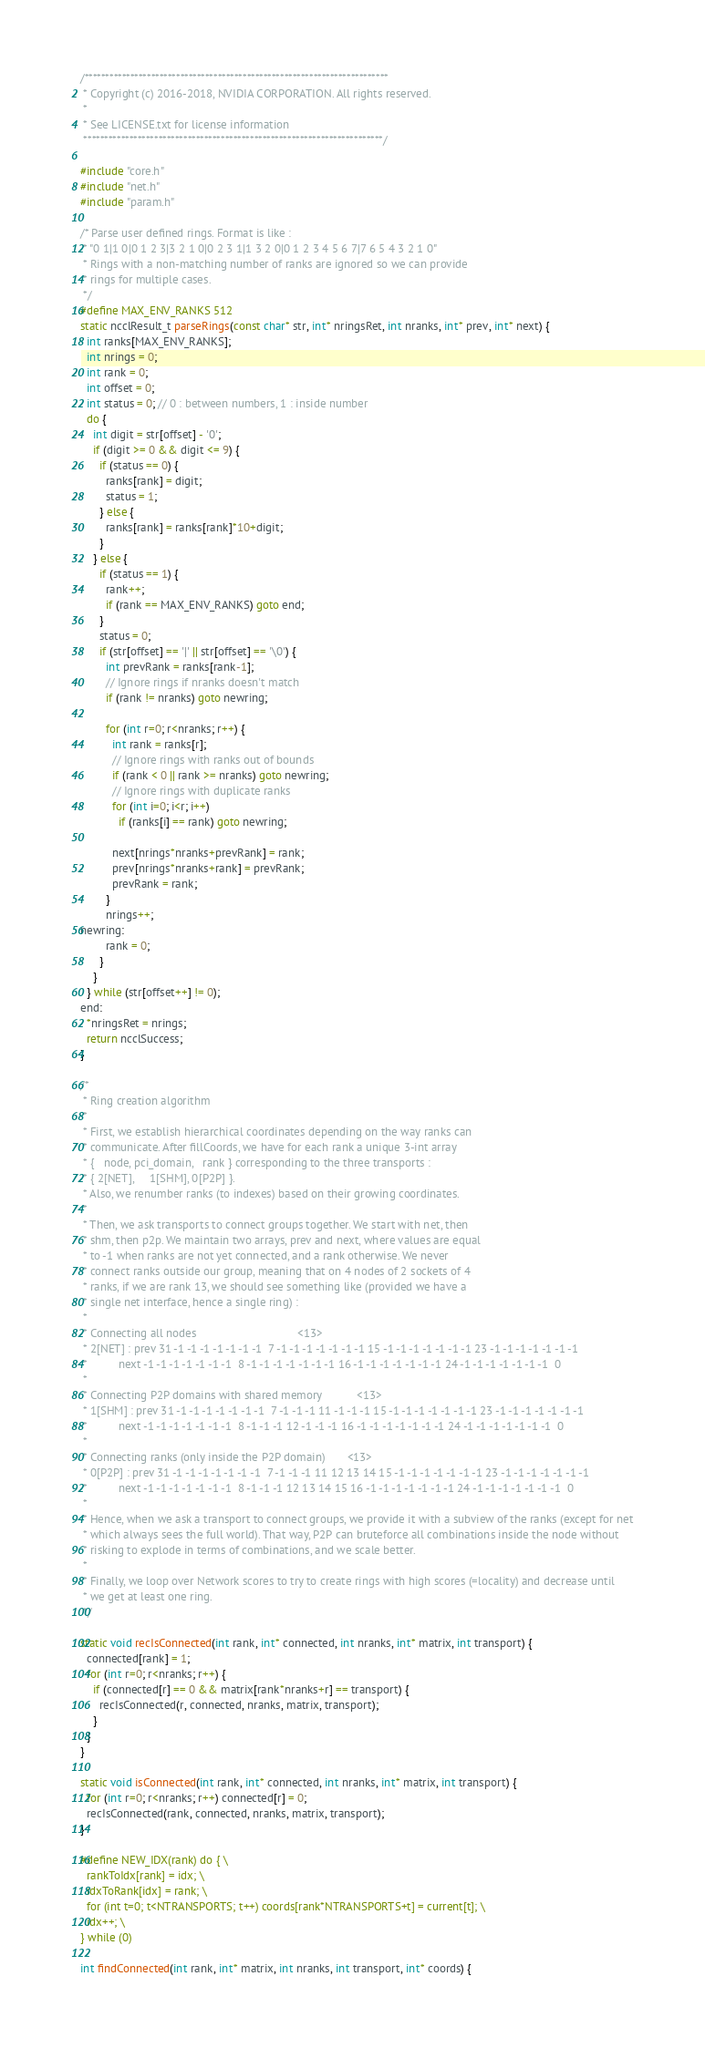Convert code to text. <code><loc_0><loc_0><loc_500><loc_500><_Cuda_>/*************************************************************************
 * Copyright (c) 2016-2018, NVIDIA CORPORATION. All rights reserved.
 *
 * See LICENSE.txt for license information
 ************************************************************************/

#include "core.h"
#include "net.h"
#include "param.h"

/* Parse user defined rings. Format is like :
 * "0 1|1 0|0 1 2 3|3 2 1 0|0 2 3 1|1 3 2 0|0 1 2 3 4 5 6 7|7 6 5 4 3 2 1 0"
 * Rings with a non-matching number of ranks are ignored so we can provide
 * rings for multiple cases.
 */
#define MAX_ENV_RANKS 512
static ncclResult_t parseRings(const char* str, int* nringsRet, int nranks, int* prev, int* next) {
  int ranks[MAX_ENV_RANKS];
  int nrings = 0;
  int rank = 0;
  int offset = 0;
  int status = 0; // 0 : between numbers, 1 : inside number
  do {
    int digit = str[offset] - '0';
    if (digit >= 0 && digit <= 9) {
      if (status == 0) {
        ranks[rank] = digit;
        status = 1;
      } else {
        ranks[rank] = ranks[rank]*10+digit;
      }
    } else {
      if (status == 1) {
        rank++;
        if (rank == MAX_ENV_RANKS) goto end;
      }
      status = 0;
      if (str[offset] == '|' || str[offset] == '\0') {
        int prevRank = ranks[rank-1];
        // Ignore rings if nranks doesn't match
        if (rank != nranks) goto newring;

        for (int r=0; r<nranks; r++) {
          int rank = ranks[r];
          // Ignore rings with ranks out of bounds
          if (rank < 0 || rank >= nranks) goto newring;
          // Ignore rings with duplicate ranks
          for (int i=0; i<r; i++)
            if (ranks[i] == rank) goto newring;

          next[nrings*nranks+prevRank] = rank;
          prev[nrings*nranks+rank] = prevRank;
          prevRank = rank;
        }
        nrings++;
newring:
        rank = 0;
      }
    }
  } while (str[offset++] != 0);
end:
  *nringsRet = nrings;
  return ncclSuccess;
}

/*
 * Ring creation algorithm
 *
 * First, we establish hierarchical coordinates depending on the way ranks can
 * communicate. After fillCoords, we have for each rank a unique 3-int array
 * {   node, pci_domain,   rank } corresponding to the three transports :
 * { 2[NET],     1[SHM], 0[P2P] }.
 * Also, we renumber ranks (to indexes) based on their growing coordinates.
 *
 * Then, we ask transports to connect groups together. We start with net, then
 * shm, then p2p. We maintain two arrays, prev and next, where values are equal
 * to -1 when ranks are not yet connected, and a rank otherwise. We never
 * connect ranks outside our group, meaning that on 4 nodes of 2 sockets of 4
 * ranks, if we are rank 13, we should see something like (provided we have a
 * single net interface, hence a single ring) :
 *
 * Connecting all nodes                                <13>
 * 2[NET] : prev 31 -1 -1 -1 -1 -1 -1 -1  7 -1 -1 -1 -1 -1 -1 -1 15 -1 -1 -1 -1 -1 -1 -1 23 -1 -1 -1 -1 -1 -1 -1
 *          next -1 -1 -1 -1 -1 -1 -1  8 -1 -1 -1 -1 -1 -1 -1 16 -1 -1 -1 -1 -1 -1 -1 24 -1 -1 -1 -1 -1 -1 -1  0
 *
 * Connecting P2P domains with shared memory           <13>
 * 1[SHM] : prev 31 -1 -1 -1 -1 -1 -1 -1  7 -1 -1 -1 11 -1 -1 -1 15 -1 -1 -1 -1 -1 -1 -1 23 -1 -1 -1 -1 -1 -1 -1
 *          next -1 -1 -1 -1 -1 -1 -1  8 -1 -1 -1 12 -1 -1 -1 16 -1 -1 -1 -1 -1 -1 -1 24 -1 -1 -1 -1 -1 -1 -1  0
 *
 * Connecting ranks (only inside the P2P domain)       <13>
 * 0[P2P] : prev 31 -1 -1 -1 -1 -1 -1 -1  7 -1 -1 -1 11 12 13 14 15 -1 -1 -1 -1 -1 -1 -1 23 -1 -1 -1 -1 -1 -1 -1
 *          next -1 -1 -1 -1 -1 -1 -1  8 -1 -1 -1 12 13 14 15 16 -1 -1 -1 -1 -1 -1 -1 24 -1 -1 -1 -1 -1 -1 -1  0
 *
 * Hence, when we ask a transport to connect groups, we provide it with a subview of the ranks (except for net
 * which always sees the full world). That way, P2P can bruteforce all combinations inside the node without
 * risking to explode in terms of combinations, and we scale better.
 *
 * Finally, we loop over Network scores to try to create rings with high scores (=locality) and decrease until
 * we get at least one ring.
 */

static void recIsConnected(int rank, int* connected, int nranks, int* matrix, int transport) {
  connected[rank] = 1;
  for (int r=0; r<nranks; r++) {
    if (connected[r] == 0 && matrix[rank*nranks+r] == transport) {
      recIsConnected(r, connected, nranks, matrix, transport);
    }
  }
}

static void isConnected(int rank, int* connected, int nranks, int* matrix, int transport) {
  for (int r=0; r<nranks; r++) connected[r] = 0;
  recIsConnected(rank, connected, nranks, matrix, transport);
}

#define NEW_IDX(rank) do { \
  rankToIdx[rank] = idx; \
  idxToRank[idx] = rank; \
  for (int t=0; t<NTRANSPORTS; t++) coords[rank*NTRANSPORTS+t] = current[t]; \
  idx++; \
} while (0)

int findConnected(int rank, int* matrix, int nranks, int transport, int* coords) {</code> 